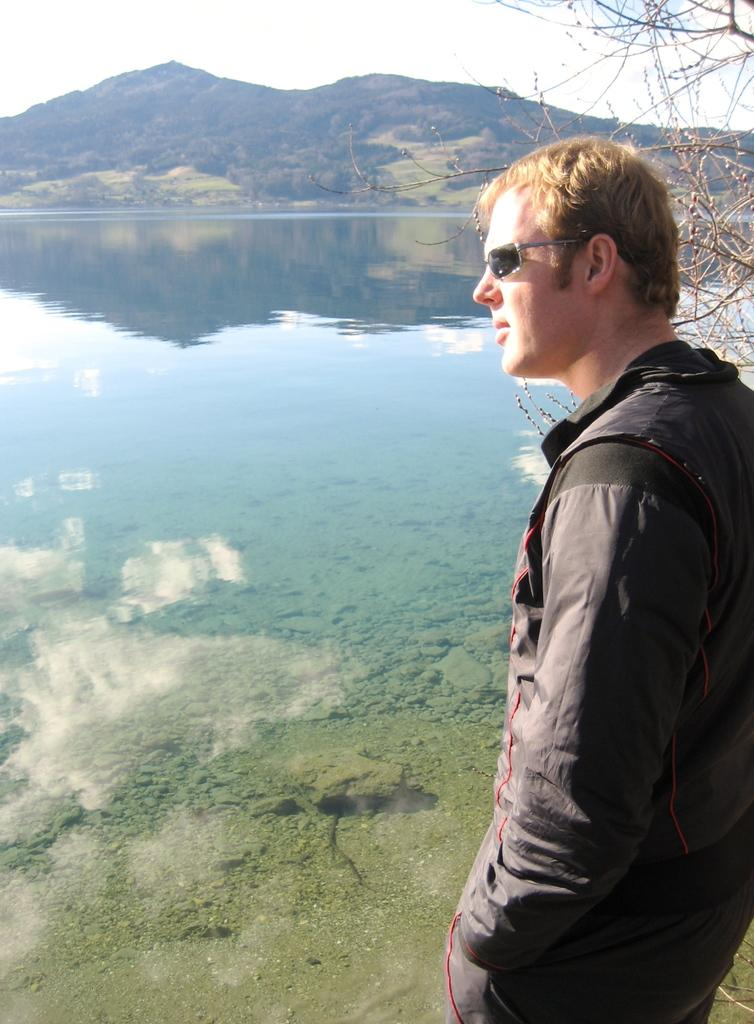Who is present in the image? There is a man in the image. What is the man wearing? The man is wearing a black jacket. What is the man doing in the image? The man is standing. What natural elements can be seen in the image? There is water, a hill, a tree, and the sky visible in the image. What type of glue is being used to attach the detail to the boot in the image? There is no detail or boot present in the image, so it is not possible to determine what type of glue might be used. 